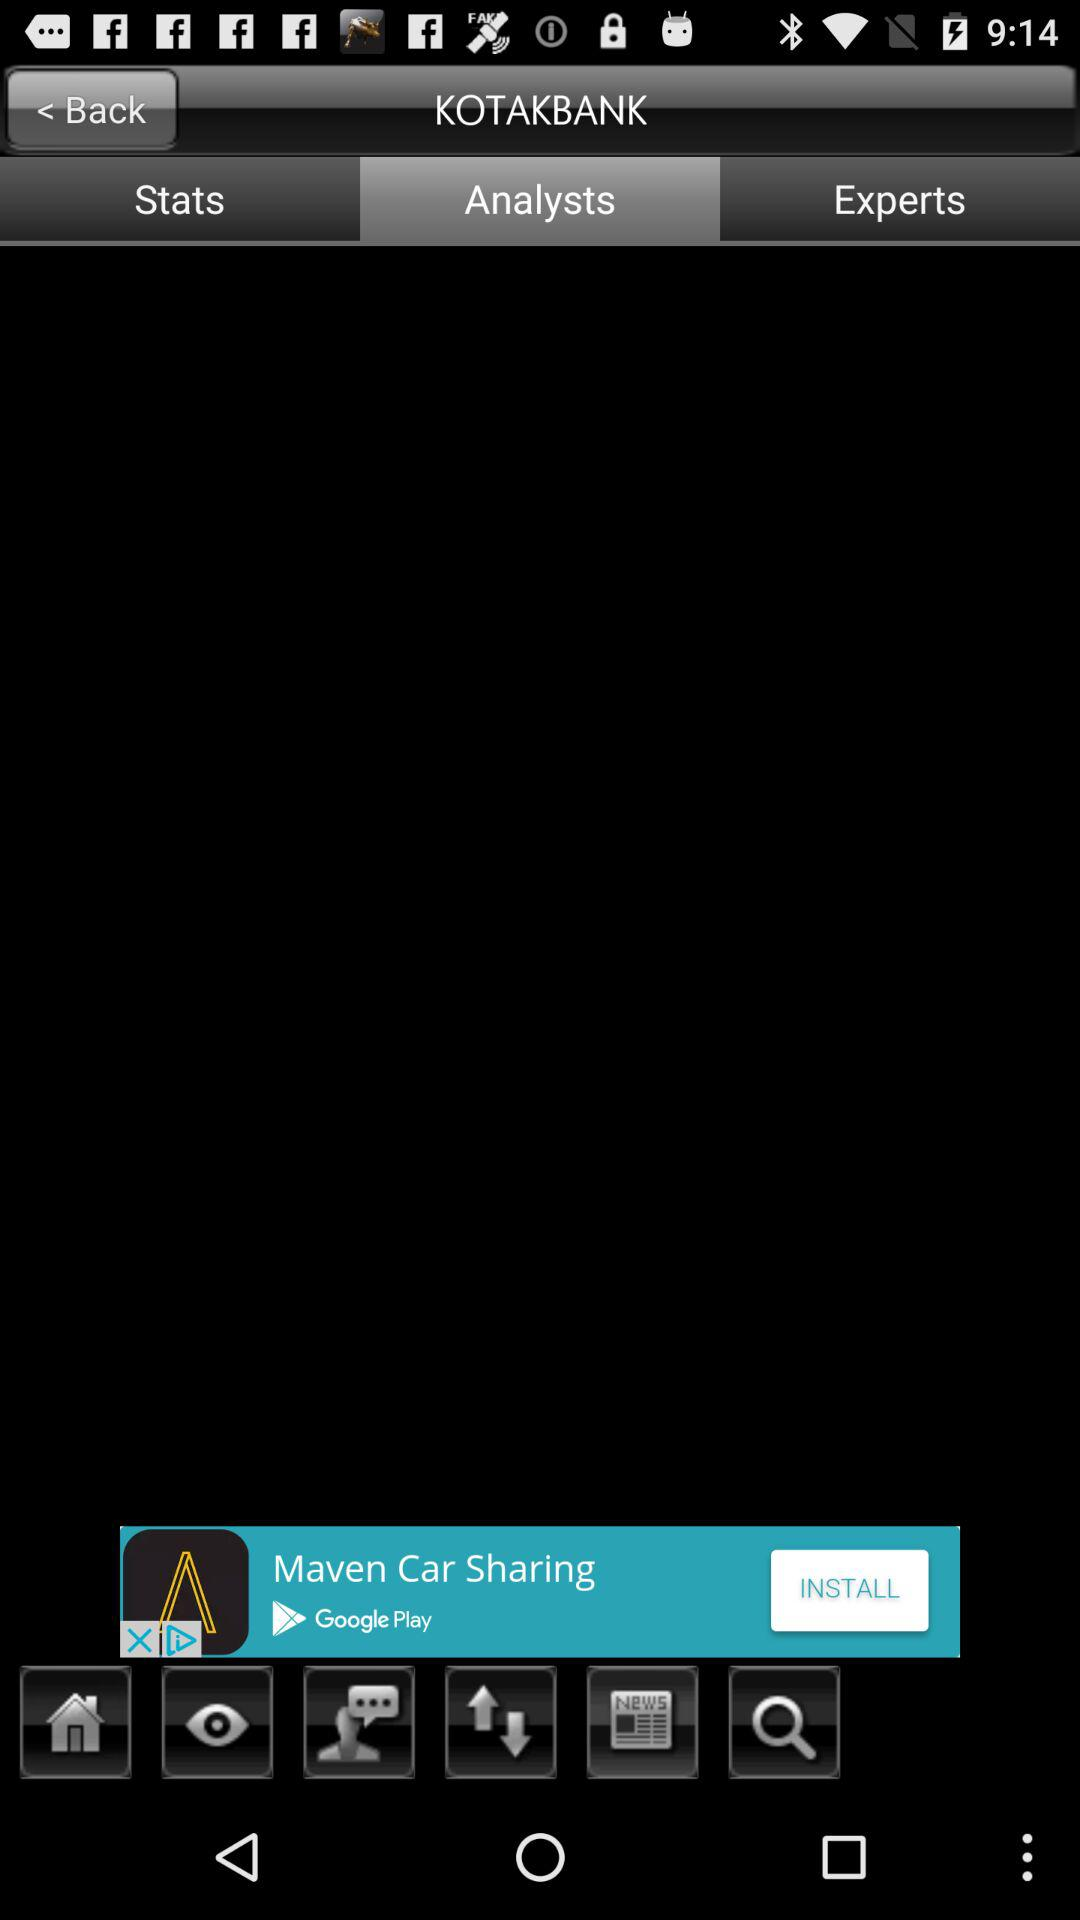What is the app title? The app title is "KOTAKBANK". 